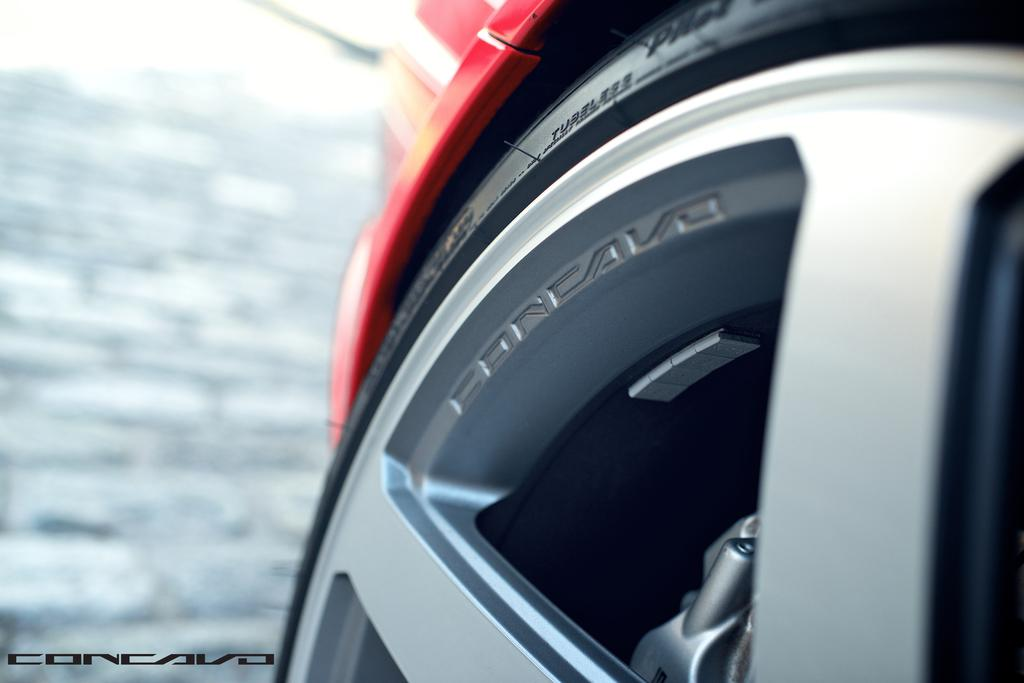What is the main object in the image? There is a vehicle wheel in the image. What is the wheel's composition? The wheel has a tyre, which is attached to spokes. How would you describe the background of the image? The background of the image appears blurry. Is there any additional information or marking on the image? Yes, there is a watermark on the image. What type of pies are being baked in the background of the image? There is no mention of pies or baking in the image; it features a vehicle wheel with a tyre and spokes. Can you tell me the name of the person who made the wheel in the image? There is no information about the person who made the wheel in the image, nor is there any name mentioned. 